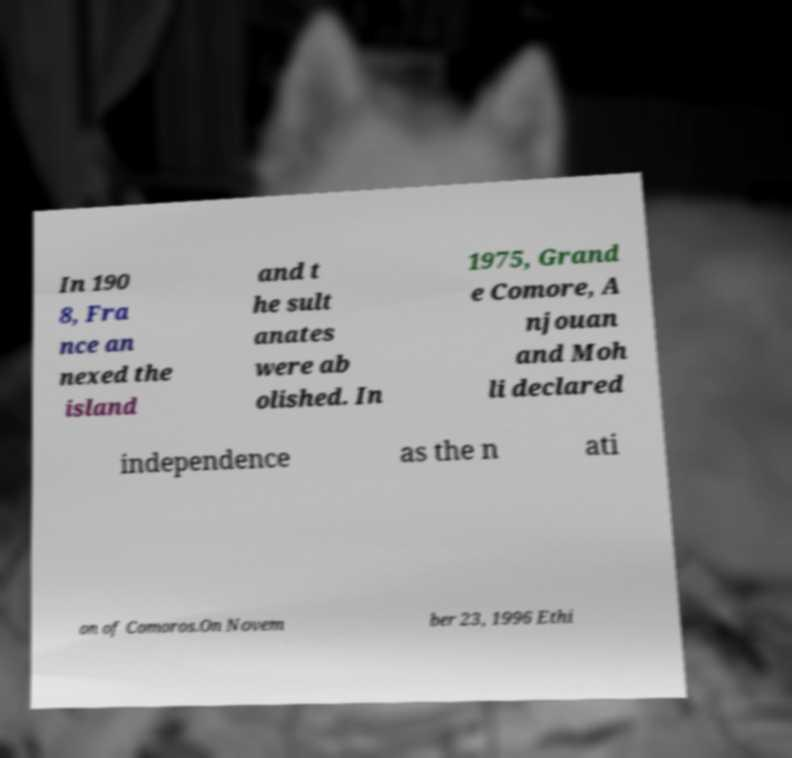Could you extract and type out the text from this image? In 190 8, Fra nce an nexed the island and t he sult anates were ab olished. In 1975, Grand e Comore, A njouan and Moh li declared independence as the n ati on of Comoros.On Novem ber 23, 1996 Ethi 